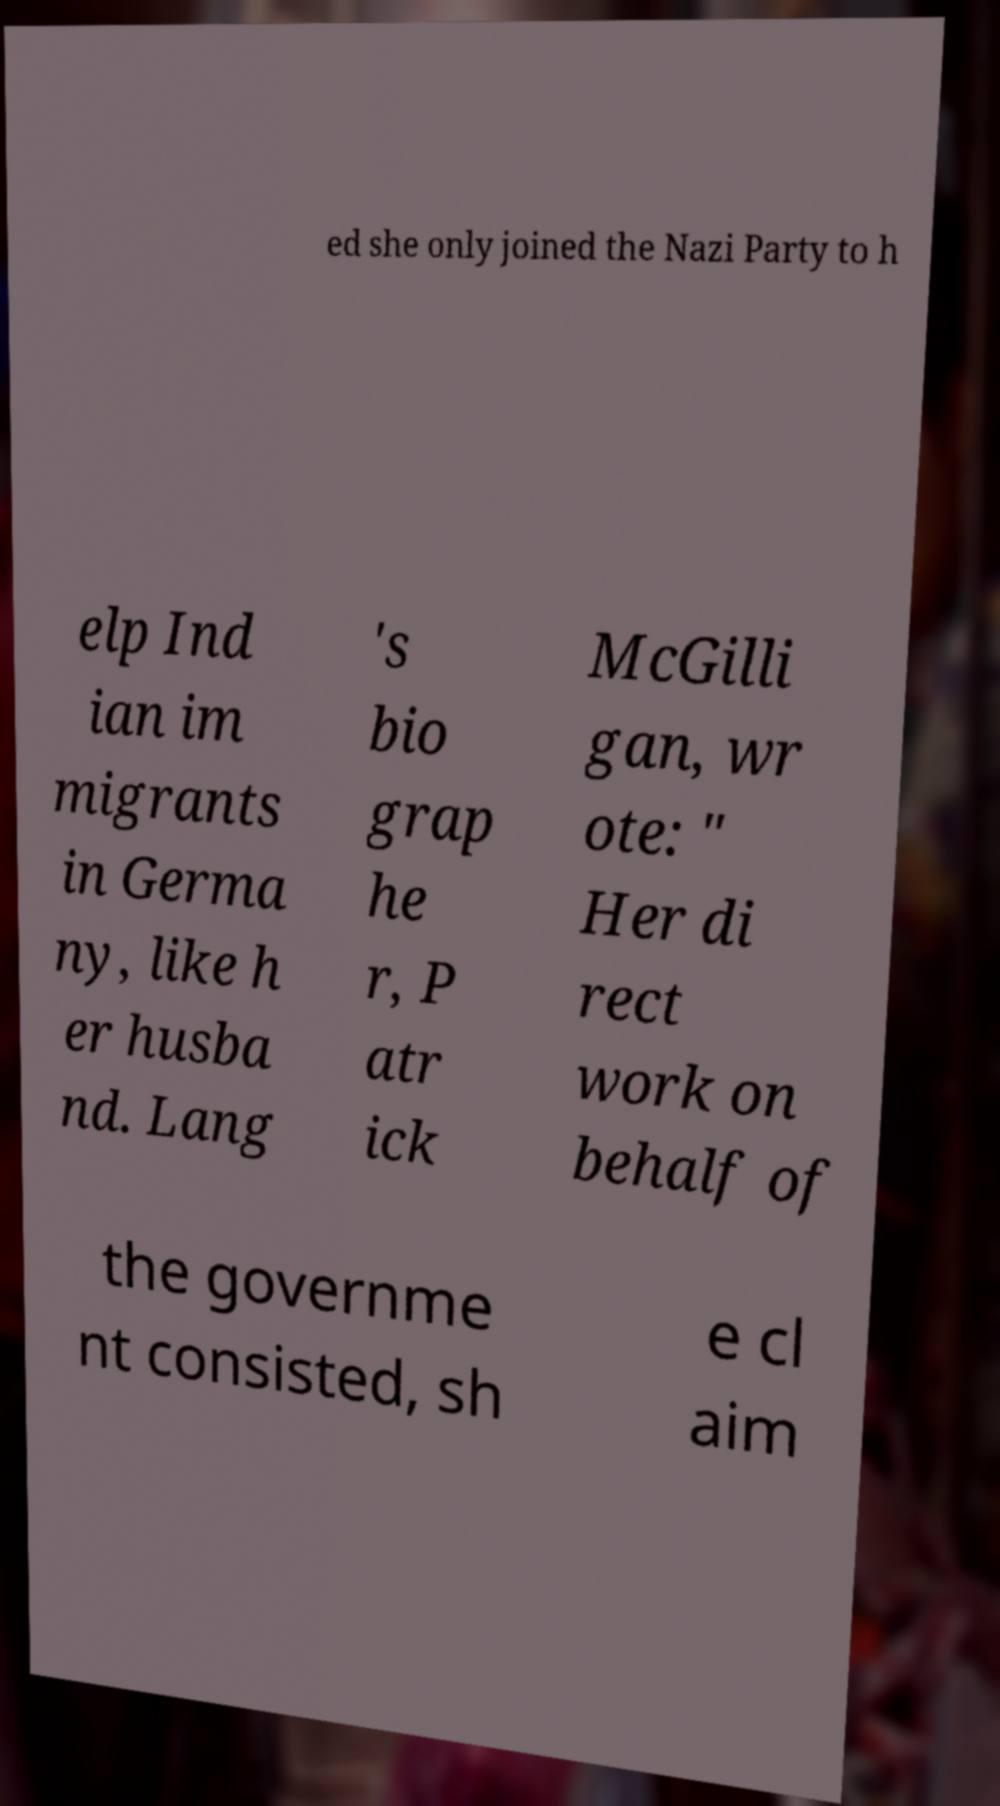Could you assist in decoding the text presented in this image and type it out clearly? ed she only joined the Nazi Party to h elp Ind ian im migrants in Germa ny, like h er husba nd. Lang 's bio grap he r, P atr ick McGilli gan, wr ote: " Her di rect work on behalf of the governme nt consisted, sh e cl aim 